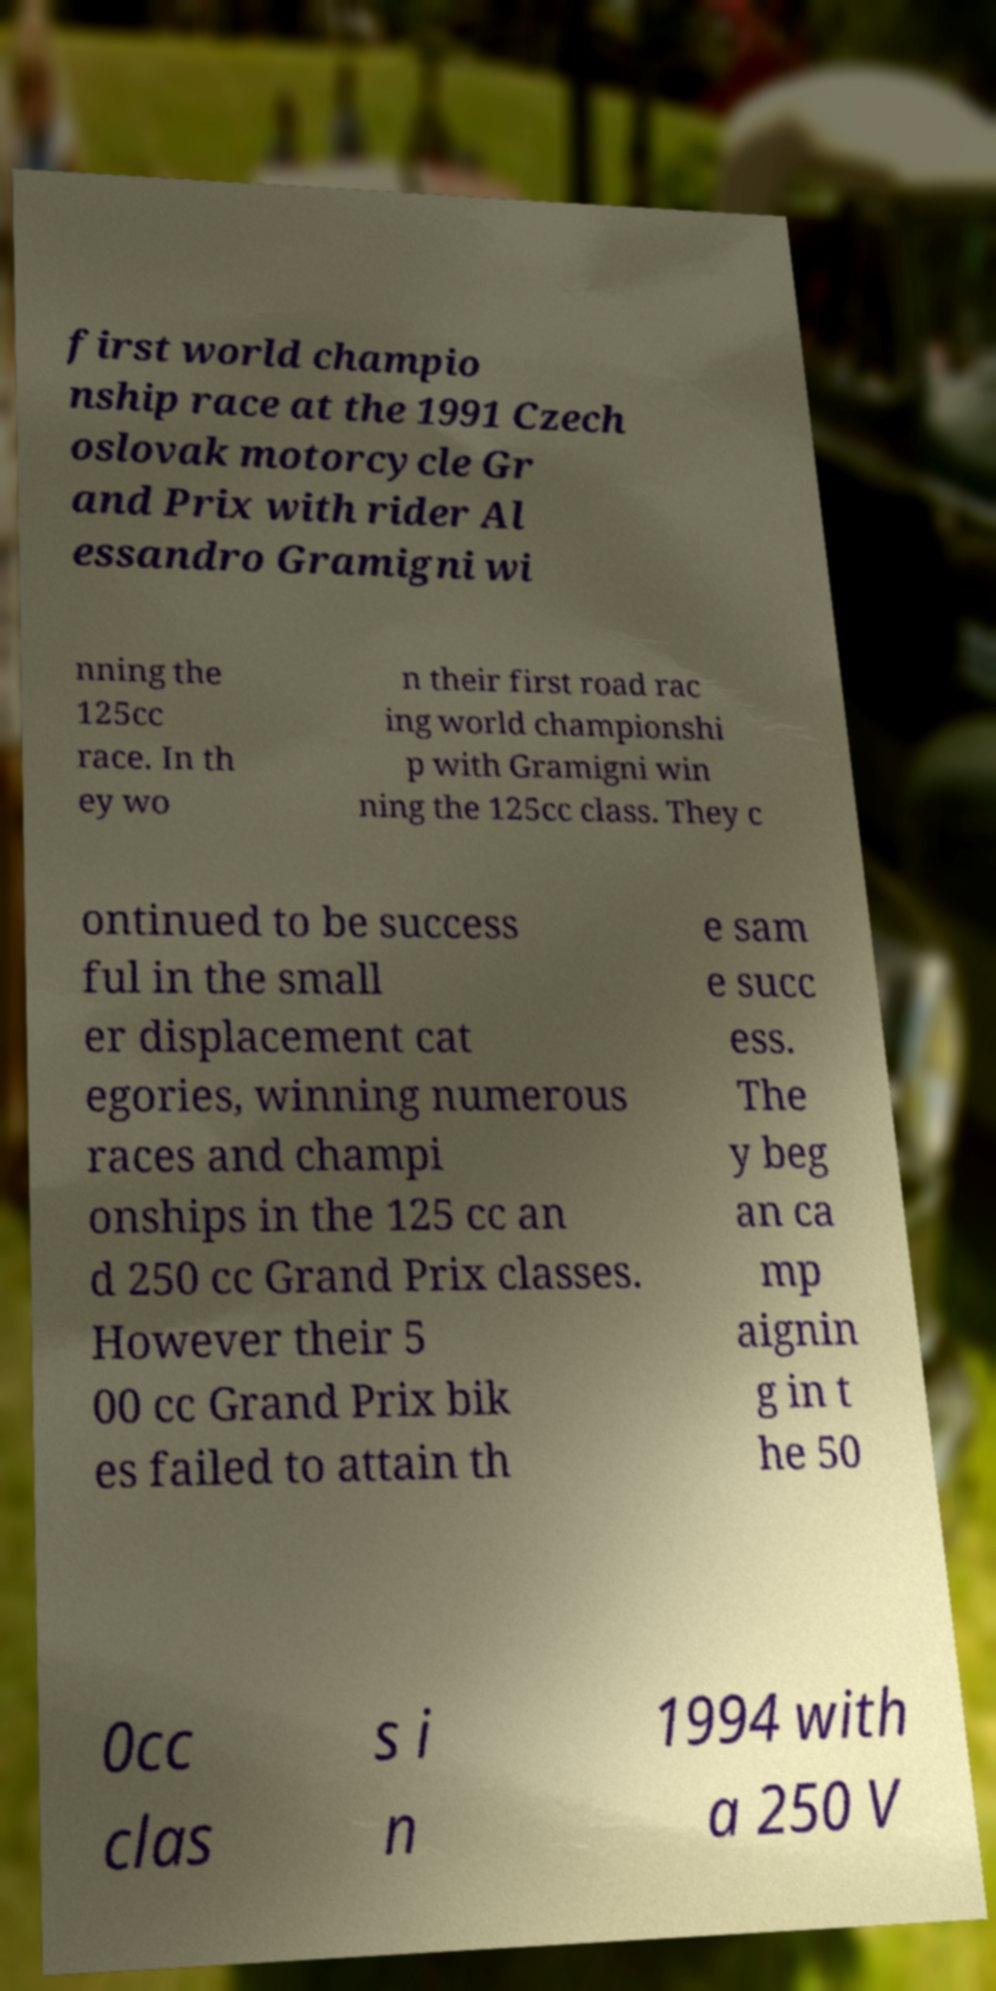There's text embedded in this image that I need extracted. Can you transcribe it verbatim? first world champio nship race at the 1991 Czech oslovak motorcycle Gr and Prix with rider Al essandro Gramigni wi nning the 125cc race. In th ey wo n their first road rac ing world championshi p with Gramigni win ning the 125cc class. They c ontinued to be success ful in the small er displacement cat egories, winning numerous races and champi onships in the 125 cc an d 250 cc Grand Prix classes. However their 5 00 cc Grand Prix bik es failed to attain th e sam e succ ess. The y beg an ca mp aignin g in t he 50 0cc clas s i n 1994 with a 250 V 